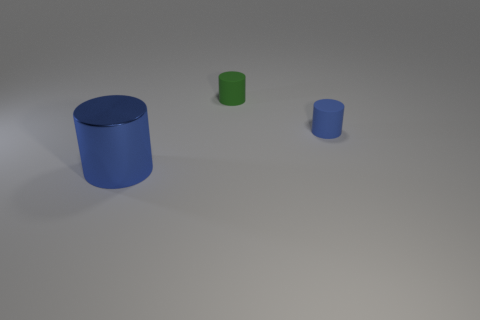How big is the matte object that is in front of the rubber thing that is to the left of the tiny blue matte object?
Your answer should be compact. Small. What is the cylinder that is to the right of the large blue metallic cylinder and left of the blue rubber thing made of?
Keep it short and to the point. Rubber. What number of other things are there of the same size as the green matte cylinder?
Make the answer very short. 1. The shiny cylinder has what color?
Make the answer very short. Blue. Does the tiny cylinder in front of the small green cylinder have the same color as the cylinder to the left of the green matte object?
Your answer should be very brief. Yes. How big is the green rubber cylinder?
Provide a succinct answer. Small. There is a rubber object behind the tiny blue rubber object; what is its size?
Provide a succinct answer. Small. What is the shape of the object that is right of the metal object and on the left side of the tiny blue thing?
Your answer should be very brief. Cylinder. How many other objects are the same shape as the big metallic object?
Provide a short and direct response. 2. The matte object that is the same size as the green cylinder is what color?
Your answer should be very brief. Blue. 